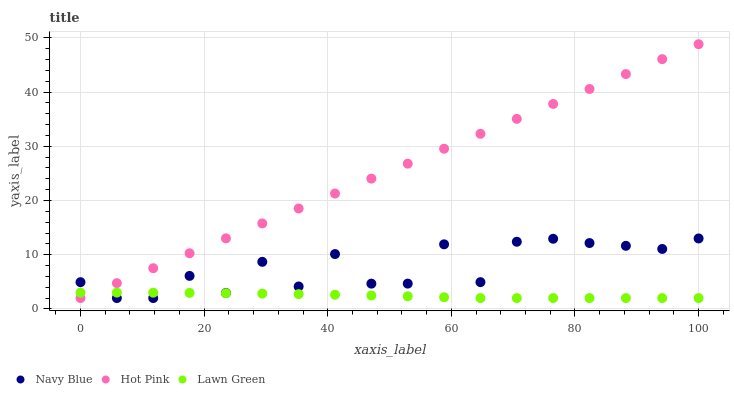Does Lawn Green have the minimum area under the curve?
Answer yes or no. Yes. Does Hot Pink have the maximum area under the curve?
Answer yes or no. Yes. Does Hot Pink have the minimum area under the curve?
Answer yes or no. No. Does Lawn Green have the maximum area under the curve?
Answer yes or no. No. Is Hot Pink the smoothest?
Answer yes or no. Yes. Is Navy Blue the roughest?
Answer yes or no. Yes. Is Lawn Green the smoothest?
Answer yes or no. No. Is Lawn Green the roughest?
Answer yes or no. No. Does Navy Blue have the lowest value?
Answer yes or no. Yes. Does Hot Pink have the highest value?
Answer yes or no. Yes. Does Lawn Green have the highest value?
Answer yes or no. No. Does Navy Blue intersect Lawn Green?
Answer yes or no. Yes. Is Navy Blue less than Lawn Green?
Answer yes or no. No. Is Navy Blue greater than Lawn Green?
Answer yes or no. No. 